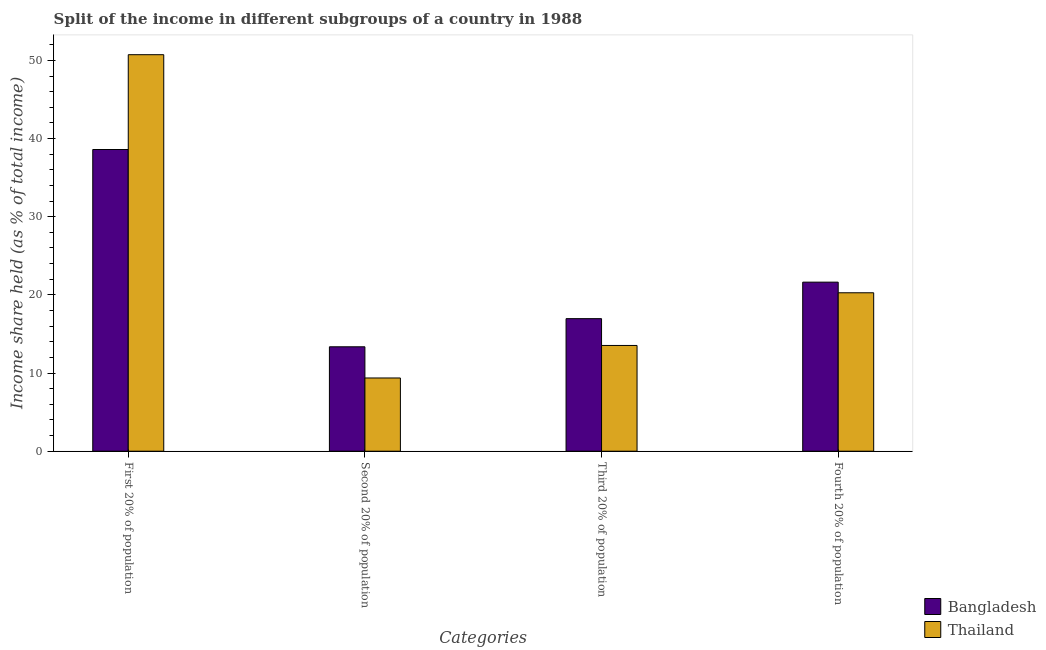How many different coloured bars are there?
Provide a succinct answer. 2. Are the number of bars per tick equal to the number of legend labels?
Offer a terse response. Yes. Are the number of bars on each tick of the X-axis equal?
Give a very brief answer. Yes. How many bars are there on the 3rd tick from the left?
Provide a short and direct response. 2. How many bars are there on the 3rd tick from the right?
Your answer should be very brief. 2. What is the label of the 4th group of bars from the left?
Provide a succinct answer. Fourth 20% of population. What is the share of the income held by fourth 20% of the population in Bangladesh?
Ensure brevity in your answer.  21.63. Across all countries, what is the maximum share of the income held by first 20% of the population?
Offer a terse response. 50.73. Across all countries, what is the minimum share of the income held by third 20% of the population?
Keep it short and to the point. 13.53. In which country was the share of the income held by third 20% of the population maximum?
Provide a succinct answer. Bangladesh. In which country was the share of the income held by third 20% of the population minimum?
Your response must be concise. Thailand. What is the total share of the income held by first 20% of the population in the graph?
Provide a succinct answer. 89.33. What is the difference between the share of the income held by fourth 20% of the population in Bangladesh and that in Thailand?
Give a very brief answer. 1.36. What is the difference between the share of the income held by fourth 20% of the population in Thailand and the share of the income held by third 20% of the population in Bangladesh?
Keep it short and to the point. 3.31. What is the average share of the income held by third 20% of the population per country?
Keep it short and to the point. 15.25. What is the difference between the share of the income held by first 20% of the population and share of the income held by fourth 20% of the population in Thailand?
Offer a terse response. 30.46. In how many countries, is the share of the income held by fourth 20% of the population greater than 30 %?
Your answer should be very brief. 0. What is the ratio of the share of the income held by first 20% of the population in Thailand to that in Bangladesh?
Ensure brevity in your answer.  1.31. Is the difference between the share of the income held by second 20% of the population in Bangladesh and Thailand greater than the difference between the share of the income held by fourth 20% of the population in Bangladesh and Thailand?
Offer a terse response. Yes. What is the difference between the highest and the second highest share of the income held by second 20% of the population?
Give a very brief answer. 3.99. What is the difference between the highest and the lowest share of the income held by third 20% of the population?
Provide a short and direct response. 3.43. In how many countries, is the share of the income held by second 20% of the population greater than the average share of the income held by second 20% of the population taken over all countries?
Your answer should be compact. 1. Is the sum of the share of the income held by fourth 20% of the population in Bangladesh and Thailand greater than the maximum share of the income held by second 20% of the population across all countries?
Your answer should be very brief. Yes. Is it the case that in every country, the sum of the share of the income held by second 20% of the population and share of the income held by fourth 20% of the population is greater than the sum of share of the income held by first 20% of the population and share of the income held by third 20% of the population?
Give a very brief answer. No. What does the 1st bar from the left in Second 20% of population represents?
Your answer should be compact. Bangladesh. Is it the case that in every country, the sum of the share of the income held by first 20% of the population and share of the income held by second 20% of the population is greater than the share of the income held by third 20% of the population?
Offer a very short reply. Yes. How are the legend labels stacked?
Your answer should be compact. Vertical. What is the title of the graph?
Make the answer very short. Split of the income in different subgroups of a country in 1988. Does "Philippines" appear as one of the legend labels in the graph?
Offer a terse response. No. What is the label or title of the X-axis?
Give a very brief answer. Categories. What is the label or title of the Y-axis?
Offer a very short reply. Income share held (as % of total income). What is the Income share held (as % of total income) in Bangladesh in First 20% of population?
Offer a terse response. 38.6. What is the Income share held (as % of total income) of Thailand in First 20% of population?
Provide a short and direct response. 50.73. What is the Income share held (as % of total income) of Bangladesh in Second 20% of population?
Offer a very short reply. 13.36. What is the Income share held (as % of total income) in Thailand in Second 20% of population?
Your response must be concise. 9.37. What is the Income share held (as % of total income) in Bangladesh in Third 20% of population?
Keep it short and to the point. 16.96. What is the Income share held (as % of total income) in Thailand in Third 20% of population?
Your answer should be very brief. 13.53. What is the Income share held (as % of total income) of Bangladesh in Fourth 20% of population?
Provide a short and direct response. 21.63. What is the Income share held (as % of total income) in Thailand in Fourth 20% of population?
Provide a succinct answer. 20.27. Across all Categories, what is the maximum Income share held (as % of total income) of Bangladesh?
Provide a short and direct response. 38.6. Across all Categories, what is the maximum Income share held (as % of total income) in Thailand?
Offer a very short reply. 50.73. Across all Categories, what is the minimum Income share held (as % of total income) in Bangladesh?
Your answer should be very brief. 13.36. Across all Categories, what is the minimum Income share held (as % of total income) in Thailand?
Give a very brief answer. 9.37. What is the total Income share held (as % of total income) in Bangladesh in the graph?
Offer a terse response. 90.55. What is the total Income share held (as % of total income) of Thailand in the graph?
Your response must be concise. 93.9. What is the difference between the Income share held (as % of total income) of Bangladesh in First 20% of population and that in Second 20% of population?
Keep it short and to the point. 25.24. What is the difference between the Income share held (as % of total income) in Thailand in First 20% of population and that in Second 20% of population?
Ensure brevity in your answer.  41.36. What is the difference between the Income share held (as % of total income) in Bangladesh in First 20% of population and that in Third 20% of population?
Provide a short and direct response. 21.64. What is the difference between the Income share held (as % of total income) of Thailand in First 20% of population and that in Third 20% of population?
Keep it short and to the point. 37.2. What is the difference between the Income share held (as % of total income) of Bangladesh in First 20% of population and that in Fourth 20% of population?
Offer a terse response. 16.97. What is the difference between the Income share held (as % of total income) in Thailand in First 20% of population and that in Fourth 20% of population?
Your answer should be compact. 30.46. What is the difference between the Income share held (as % of total income) in Bangladesh in Second 20% of population and that in Third 20% of population?
Your answer should be compact. -3.6. What is the difference between the Income share held (as % of total income) in Thailand in Second 20% of population and that in Third 20% of population?
Your response must be concise. -4.16. What is the difference between the Income share held (as % of total income) of Bangladesh in Second 20% of population and that in Fourth 20% of population?
Your answer should be compact. -8.27. What is the difference between the Income share held (as % of total income) in Bangladesh in Third 20% of population and that in Fourth 20% of population?
Make the answer very short. -4.67. What is the difference between the Income share held (as % of total income) of Thailand in Third 20% of population and that in Fourth 20% of population?
Offer a terse response. -6.74. What is the difference between the Income share held (as % of total income) in Bangladesh in First 20% of population and the Income share held (as % of total income) in Thailand in Second 20% of population?
Offer a terse response. 29.23. What is the difference between the Income share held (as % of total income) in Bangladesh in First 20% of population and the Income share held (as % of total income) in Thailand in Third 20% of population?
Your answer should be compact. 25.07. What is the difference between the Income share held (as % of total income) in Bangladesh in First 20% of population and the Income share held (as % of total income) in Thailand in Fourth 20% of population?
Provide a short and direct response. 18.33. What is the difference between the Income share held (as % of total income) in Bangladesh in Second 20% of population and the Income share held (as % of total income) in Thailand in Third 20% of population?
Your response must be concise. -0.17. What is the difference between the Income share held (as % of total income) in Bangladesh in Second 20% of population and the Income share held (as % of total income) in Thailand in Fourth 20% of population?
Your response must be concise. -6.91. What is the difference between the Income share held (as % of total income) of Bangladesh in Third 20% of population and the Income share held (as % of total income) of Thailand in Fourth 20% of population?
Keep it short and to the point. -3.31. What is the average Income share held (as % of total income) of Bangladesh per Categories?
Keep it short and to the point. 22.64. What is the average Income share held (as % of total income) of Thailand per Categories?
Keep it short and to the point. 23.48. What is the difference between the Income share held (as % of total income) of Bangladesh and Income share held (as % of total income) of Thailand in First 20% of population?
Offer a terse response. -12.13. What is the difference between the Income share held (as % of total income) in Bangladesh and Income share held (as % of total income) in Thailand in Second 20% of population?
Make the answer very short. 3.99. What is the difference between the Income share held (as % of total income) in Bangladesh and Income share held (as % of total income) in Thailand in Third 20% of population?
Your answer should be compact. 3.43. What is the difference between the Income share held (as % of total income) in Bangladesh and Income share held (as % of total income) in Thailand in Fourth 20% of population?
Your answer should be compact. 1.36. What is the ratio of the Income share held (as % of total income) in Bangladesh in First 20% of population to that in Second 20% of population?
Provide a short and direct response. 2.89. What is the ratio of the Income share held (as % of total income) of Thailand in First 20% of population to that in Second 20% of population?
Offer a terse response. 5.41. What is the ratio of the Income share held (as % of total income) of Bangladesh in First 20% of population to that in Third 20% of population?
Ensure brevity in your answer.  2.28. What is the ratio of the Income share held (as % of total income) of Thailand in First 20% of population to that in Third 20% of population?
Give a very brief answer. 3.75. What is the ratio of the Income share held (as % of total income) in Bangladesh in First 20% of population to that in Fourth 20% of population?
Ensure brevity in your answer.  1.78. What is the ratio of the Income share held (as % of total income) of Thailand in First 20% of population to that in Fourth 20% of population?
Provide a succinct answer. 2.5. What is the ratio of the Income share held (as % of total income) of Bangladesh in Second 20% of population to that in Third 20% of population?
Provide a succinct answer. 0.79. What is the ratio of the Income share held (as % of total income) of Thailand in Second 20% of population to that in Third 20% of population?
Ensure brevity in your answer.  0.69. What is the ratio of the Income share held (as % of total income) in Bangladesh in Second 20% of population to that in Fourth 20% of population?
Make the answer very short. 0.62. What is the ratio of the Income share held (as % of total income) of Thailand in Second 20% of population to that in Fourth 20% of population?
Make the answer very short. 0.46. What is the ratio of the Income share held (as % of total income) of Bangladesh in Third 20% of population to that in Fourth 20% of population?
Your answer should be very brief. 0.78. What is the ratio of the Income share held (as % of total income) of Thailand in Third 20% of population to that in Fourth 20% of population?
Your answer should be compact. 0.67. What is the difference between the highest and the second highest Income share held (as % of total income) of Bangladesh?
Offer a terse response. 16.97. What is the difference between the highest and the second highest Income share held (as % of total income) of Thailand?
Offer a terse response. 30.46. What is the difference between the highest and the lowest Income share held (as % of total income) of Bangladesh?
Provide a succinct answer. 25.24. What is the difference between the highest and the lowest Income share held (as % of total income) of Thailand?
Offer a terse response. 41.36. 